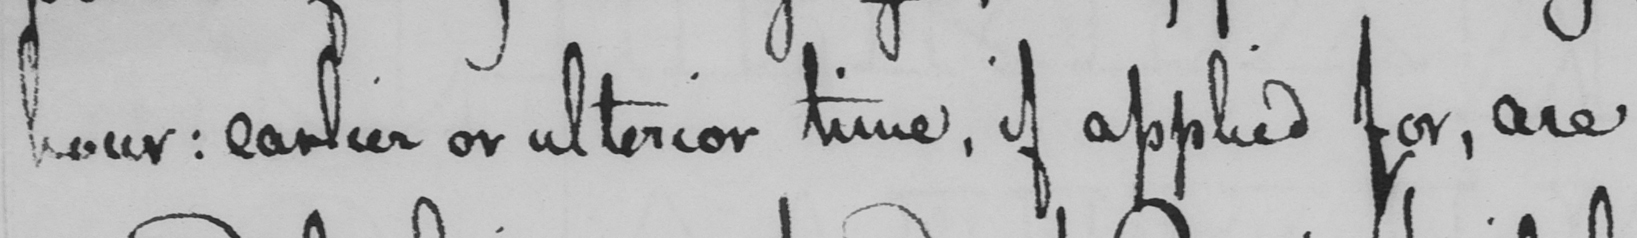What does this handwritten line say? hour: earlier or ulterior time, if applied for, are 